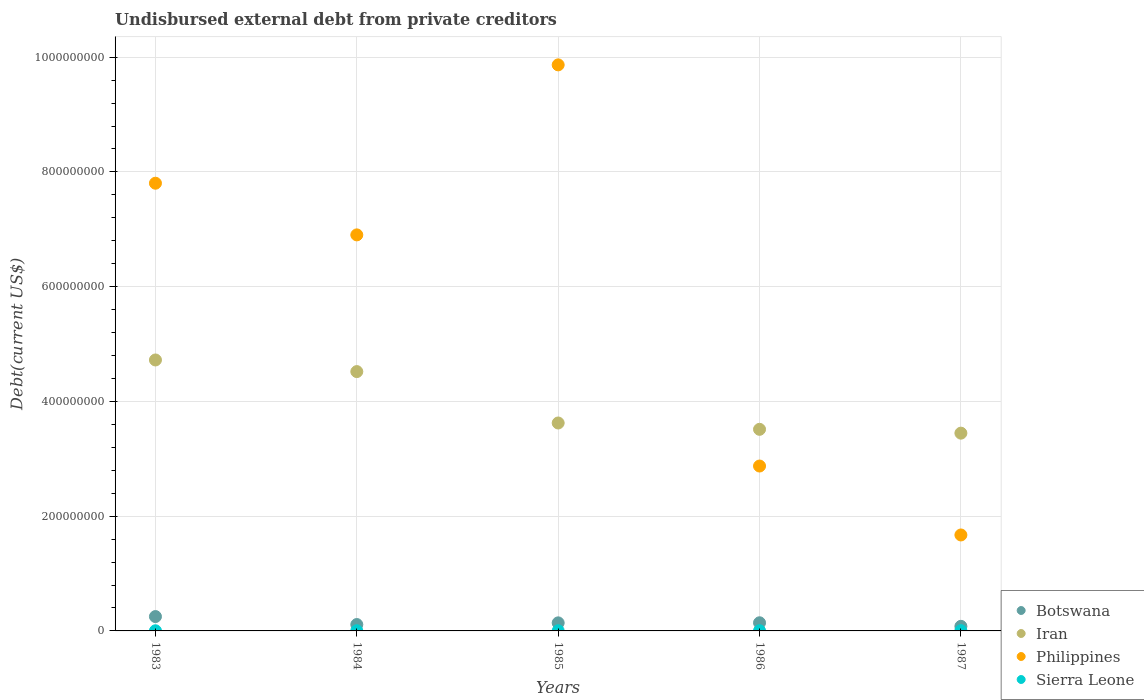How many different coloured dotlines are there?
Your answer should be compact. 4. What is the total debt in Botswana in 1986?
Your response must be concise. 1.42e+07. Across all years, what is the maximum total debt in Philippines?
Ensure brevity in your answer.  9.87e+08. Across all years, what is the minimum total debt in Botswana?
Give a very brief answer. 7.99e+06. In which year was the total debt in Sierra Leone maximum?
Your answer should be very brief. 1987. What is the total total debt in Botswana in the graph?
Provide a succinct answer. 7.24e+07. What is the difference between the total debt in Philippines in 1983 and that in 1984?
Your answer should be compact. 9.00e+07. What is the difference between the total debt in Botswana in 1983 and the total debt in Sierra Leone in 1987?
Make the answer very short. 2.46e+07. What is the average total debt in Philippines per year?
Make the answer very short. 5.82e+08. In the year 1984, what is the difference between the total debt in Sierra Leone and total debt in Botswana?
Keep it short and to the point. -1.08e+07. In how many years, is the total debt in Sierra Leone greater than 160000000 US$?
Provide a succinct answer. 0. What is the ratio of the total debt in Sierra Leone in 1983 to that in 1985?
Make the answer very short. 0.91. Is the total debt in Iran in 1983 less than that in 1985?
Give a very brief answer. No. Is the difference between the total debt in Sierra Leone in 1984 and 1985 greater than the difference between the total debt in Botswana in 1984 and 1985?
Make the answer very short. Yes. What is the difference between the highest and the second highest total debt in Sierra Leone?
Ensure brevity in your answer.  7.20e+04. What is the difference between the highest and the lowest total debt in Botswana?
Make the answer very short. 1.70e+07. In how many years, is the total debt in Iran greater than the average total debt in Iran taken over all years?
Ensure brevity in your answer.  2. Is the sum of the total debt in Sierra Leone in 1985 and 1987 greater than the maximum total debt in Botswana across all years?
Make the answer very short. No. Is it the case that in every year, the sum of the total debt in Iran and total debt in Sierra Leone  is greater than the total debt in Philippines?
Keep it short and to the point. No. Is the total debt in Philippines strictly less than the total debt in Botswana over the years?
Give a very brief answer. No. How many dotlines are there?
Your response must be concise. 4. How many legend labels are there?
Provide a succinct answer. 4. What is the title of the graph?
Make the answer very short. Undisbursed external debt from private creditors. Does "Haiti" appear as one of the legend labels in the graph?
Offer a very short reply. No. What is the label or title of the X-axis?
Offer a terse response. Years. What is the label or title of the Y-axis?
Keep it short and to the point. Debt(current US$). What is the Debt(current US$) of Botswana in 1983?
Offer a terse response. 2.50e+07. What is the Debt(current US$) in Iran in 1983?
Make the answer very short. 4.72e+08. What is the Debt(current US$) of Philippines in 1983?
Offer a very short reply. 7.80e+08. What is the Debt(current US$) in Sierra Leone in 1983?
Provide a succinct answer. 2.67e+05. What is the Debt(current US$) in Botswana in 1984?
Your response must be concise. 1.11e+07. What is the Debt(current US$) in Iran in 1984?
Make the answer very short. 4.52e+08. What is the Debt(current US$) in Philippines in 1984?
Your answer should be compact. 6.90e+08. What is the Debt(current US$) of Sierra Leone in 1984?
Make the answer very short. 2.84e+05. What is the Debt(current US$) in Botswana in 1985?
Your answer should be compact. 1.41e+07. What is the Debt(current US$) of Iran in 1985?
Make the answer very short. 3.62e+08. What is the Debt(current US$) of Philippines in 1985?
Offer a very short reply. 9.87e+08. What is the Debt(current US$) of Sierra Leone in 1985?
Ensure brevity in your answer.  2.94e+05. What is the Debt(current US$) in Botswana in 1986?
Provide a short and direct response. 1.42e+07. What is the Debt(current US$) of Iran in 1986?
Offer a terse response. 3.51e+08. What is the Debt(current US$) of Philippines in 1986?
Ensure brevity in your answer.  2.87e+08. What is the Debt(current US$) of Sierra Leone in 1986?
Make the answer very short. 3.45e+05. What is the Debt(current US$) in Botswana in 1987?
Provide a succinct answer. 7.99e+06. What is the Debt(current US$) of Iran in 1987?
Provide a short and direct response. 3.45e+08. What is the Debt(current US$) in Philippines in 1987?
Give a very brief answer. 1.67e+08. What is the Debt(current US$) in Sierra Leone in 1987?
Give a very brief answer. 4.17e+05. Across all years, what is the maximum Debt(current US$) of Botswana?
Give a very brief answer. 2.50e+07. Across all years, what is the maximum Debt(current US$) in Iran?
Provide a succinct answer. 4.72e+08. Across all years, what is the maximum Debt(current US$) in Philippines?
Offer a terse response. 9.87e+08. Across all years, what is the maximum Debt(current US$) of Sierra Leone?
Offer a very short reply. 4.17e+05. Across all years, what is the minimum Debt(current US$) in Botswana?
Your answer should be very brief. 7.99e+06. Across all years, what is the minimum Debt(current US$) of Iran?
Your response must be concise. 3.45e+08. Across all years, what is the minimum Debt(current US$) in Philippines?
Offer a very short reply. 1.67e+08. Across all years, what is the minimum Debt(current US$) in Sierra Leone?
Keep it short and to the point. 2.67e+05. What is the total Debt(current US$) in Botswana in the graph?
Your answer should be very brief. 7.24e+07. What is the total Debt(current US$) of Iran in the graph?
Your answer should be compact. 1.98e+09. What is the total Debt(current US$) of Philippines in the graph?
Give a very brief answer. 2.91e+09. What is the total Debt(current US$) of Sierra Leone in the graph?
Ensure brevity in your answer.  1.61e+06. What is the difference between the Debt(current US$) of Botswana in 1983 and that in 1984?
Keep it short and to the point. 1.39e+07. What is the difference between the Debt(current US$) of Iran in 1983 and that in 1984?
Keep it short and to the point. 2.03e+07. What is the difference between the Debt(current US$) in Philippines in 1983 and that in 1984?
Offer a very short reply. 9.00e+07. What is the difference between the Debt(current US$) of Sierra Leone in 1983 and that in 1984?
Make the answer very short. -1.70e+04. What is the difference between the Debt(current US$) in Botswana in 1983 and that in 1985?
Give a very brief answer. 1.10e+07. What is the difference between the Debt(current US$) in Iran in 1983 and that in 1985?
Your response must be concise. 1.10e+08. What is the difference between the Debt(current US$) of Philippines in 1983 and that in 1985?
Your answer should be very brief. -2.06e+08. What is the difference between the Debt(current US$) in Sierra Leone in 1983 and that in 1985?
Your answer should be very brief. -2.70e+04. What is the difference between the Debt(current US$) of Botswana in 1983 and that in 1986?
Provide a succinct answer. 1.08e+07. What is the difference between the Debt(current US$) in Iran in 1983 and that in 1986?
Your answer should be compact. 1.21e+08. What is the difference between the Debt(current US$) in Philippines in 1983 and that in 1986?
Offer a very short reply. 4.93e+08. What is the difference between the Debt(current US$) of Sierra Leone in 1983 and that in 1986?
Give a very brief answer. -7.80e+04. What is the difference between the Debt(current US$) of Botswana in 1983 and that in 1987?
Give a very brief answer. 1.70e+07. What is the difference between the Debt(current US$) in Iran in 1983 and that in 1987?
Give a very brief answer. 1.28e+08. What is the difference between the Debt(current US$) in Philippines in 1983 and that in 1987?
Your answer should be very brief. 6.13e+08. What is the difference between the Debt(current US$) of Sierra Leone in 1983 and that in 1987?
Provide a succinct answer. -1.50e+05. What is the difference between the Debt(current US$) in Botswana in 1984 and that in 1985?
Make the answer very short. -2.93e+06. What is the difference between the Debt(current US$) in Iran in 1984 and that in 1985?
Your answer should be compact. 8.96e+07. What is the difference between the Debt(current US$) in Philippines in 1984 and that in 1985?
Make the answer very short. -2.96e+08. What is the difference between the Debt(current US$) in Sierra Leone in 1984 and that in 1985?
Keep it short and to the point. -10000. What is the difference between the Debt(current US$) of Botswana in 1984 and that in 1986?
Make the answer very short. -3.07e+06. What is the difference between the Debt(current US$) in Iran in 1984 and that in 1986?
Your response must be concise. 1.01e+08. What is the difference between the Debt(current US$) in Philippines in 1984 and that in 1986?
Offer a very short reply. 4.03e+08. What is the difference between the Debt(current US$) of Sierra Leone in 1984 and that in 1986?
Make the answer very short. -6.10e+04. What is the difference between the Debt(current US$) in Botswana in 1984 and that in 1987?
Keep it short and to the point. 3.14e+06. What is the difference between the Debt(current US$) in Iran in 1984 and that in 1987?
Ensure brevity in your answer.  1.07e+08. What is the difference between the Debt(current US$) of Philippines in 1984 and that in 1987?
Offer a terse response. 5.23e+08. What is the difference between the Debt(current US$) of Sierra Leone in 1984 and that in 1987?
Your answer should be very brief. -1.33e+05. What is the difference between the Debt(current US$) in Botswana in 1985 and that in 1986?
Make the answer very short. -1.43e+05. What is the difference between the Debt(current US$) in Iran in 1985 and that in 1986?
Keep it short and to the point. 1.10e+07. What is the difference between the Debt(current US$) of Philippines in 1985 and that in 1986?
Give a very brief answer. 6.99e+08. What is the difference between the Debt(current US$) in Sierra Leone in 1985 and that in 1986?
Offer a very short reply. -5.10e+04. What is the difference between the Debt(current US$) in Botswana in 1985 and that in 1987?
Ensure brevity in your answer.  6.06e+06. What is the difference between the Debt(current US$) in Iran in 1985 and that in 1987?
Offer a terse response. 1.77e+07. What is the difference between the Debt(current US$) of Philippines in 1985 and that in 1987?
Make the answer very short. 8.19e+08. What is the difference between the Debt(current US$) of Sierra Leone in 1985 and that in 1987?
Make the answer very short. -1.23e+05. What is the difference between the Debt(current US$) of Botswana in 1986 and that in 1987?
Provide a short and direct response. 6.21e+06. What is the difference between the Debt(current US$) in Iran in 1986 and that in 1987?
Give a very brief answer. 6.68e+06. What is the difference between the Debt(current US$) in Philippines in 1986 and that in 1987?
Your response must be concise. 1.20e+08. What is the difference between the Debt(current US$) of Sierra Leone in 1986 and that in 1987?
Give a very brief answer. -7.20e+04. What is the difference between the Debt(current US$) of Botswana in 1983 and the Debt(current US$) of Iran in 1984?
Make the answer very short. -4.27e+08. What is the difference between the Debt(current US$) of Botswana in 1983 and the Debt(current US$) of Philippines in 1984?
Ensure brevity in your answer.  -6.65e+08. What is the difference between the Debt(current US$) of Botswana in 1983 and the Debt(current US$) of Sierra Leone in 1984?
Keep it short and to the point. 2.47e+07. What is the difference between the Debt(current US$) in Iran in 1983 and the Debt(current US$) in Philippines in 1984?
Make the answer very short. -2.18e+08. What is the difference between the Debt(current US$) in Iran in 1983 and the Debt(current US$) in Sierra Leone in 1984?
Ensure brevity in your answer.  4.72e+08. What is the difference between the Debt(current US$) in Philippines in 1983 and the Debt(current US$) in Sierra Leone in 1984?
Give a very brief answer. 7.80e+08. What is the difference between the Debt(current US$) of Botswana in 1983 and the Debt(current US$) of Iran in 1985?
Make the answer very short. -3.37e+08. What is the difference between the Debt(current US$) of Botswana in 1983 and the Debt(current US$) of Philippines in 1985?
Provide a short and direct response. -9.62e+08. What is the difference between the Debt(current US$) in Botswana in 1983 and the Debt(current US$) in Sierra Leone in 1985?
Your answer should be compact. 2.47e+07. What is the difference between the Debt(current US$) in Iran in 1983 and the Debt(current US$) in Philippines in 1985?
Provide a short and direct response. -5.14e+08. What is the difference between the Debt(current US$) of Iran in 1983 and the Debt(current US$) of Sierra Leone in 1985?
Provide a succinct answer. 4.72e+08. What is the difference between the Debt(current US$) of Philippines in 1983 and the Debt(current US$) of Sierra Leone in 1985?
Give a very brief answer. 7.80e+08. What is the difference between the Debt(current US$) in Botswana in 1983 and the Debt(current US$) in Iran in 1986?
Provide a short and direct response. -3.26e+08. What is the difference between the Debt(current US$) of Botswana in 1983 and the Debt(current US$) of Philippines in 1986?
Ensure brevity in your answer.  -2.62e+08. What is the difference between the Debt(current US$) of Botswana in 1983 and the Debt(current US$) of Sierra Leone in 1986?
Offer a terse response. 2.47e+07. What is the difference between the Debt(current US$) of Iran in 1983 and the Debt(current US$) of Philippines in 1986?
Make the answer very short. 1.85e+08. What is the difference between the Debt(current US$) in Iran in 1983 and the Debt(current US$) in Sierra Leone in 1986?
Your answer should be very brief. 4.72e+08. What is the difference between the Debt(current US$) in Philippines in 1983 and the Debt(current US$) in Sierra Leone in 1986?
Provide a succinct answer. 7.80e+08. What is the difference between the Debt(current US$) of Botswana in 1983 and the Debt(current US$) of Iran in 1987?
Your response must be concise. -3.20e+08. What is the difference between the Debt(current US$) in Botswana in 1983 and the Debt(current US$) in Philippines in 1987?
Offer a very short reply. -1.42e+08. What is the difference between the Debt(current US$) of Botswana in 1983 and the Debt(current US$) of Sierra Leone in 1987?
Your response must be concise. 2.46e+07. What is the difference between the Debt(current US$) in Iran in 1983 and the Debt(current US$) in Philippines in 1987?
Provide a succinct answer. 3.05e+08. What is the difference between the Debt(current US$) of Iran in 1983 and the Debt(current US$) of Sierra Leone in 1987?
Ensure brevity in your answer.  4.72e+08. What is the difference between the Debt(current US$) in Philippines in 1983 and the Debt(current US$) in Sierra Leone in 1987?
Provide a succinct answer. 7.80e+08. What is the difference between the Debt(current US$) of Botswana in 1984 and the Debt(current US$) of Iran in 1985?
Give a very brief answer. -3.51e+08. What is the difference between the Debt(current US$) in Botswana in 1984 and the Debt(current US$) in Philippines in 1985?
Offer a very short reply. -9.75e+08. What is the difference between the Debt(current US$) of Botswana in 1984 and the Debt(current US$) of Sierra Leone in 1985?
Provide a short and direct response. 1.08e+07. What is the difference between the Debt(current US$) in Iran in 1984 and the Debt(current US$) in Philippines in 1985?
Your answer should be very brief. -5.35e+08. What is the difference between the Debt(current US$) of Iran in 1984 and the Debt(current US$) of Sierra Leone in 1985?
Provide a succinct answer. 4.52e+08. What is the difference between the Debt(current US$) in Philippines in 1984 and the Debt(current US$) in Sierra Leone in 1985?
Make the answer very short. 6.90e+08. What is the difference between the Debt(current US$) in Botswana in 1984 and the Debt(current US$) in Iran in 1986?
Your answer should be compact. -3.40e+08. What is the difference between the Debt(current US$) in Botswana in 1984 and the Debt(current US$) in Philippines in 1986?
Provide a succinct answer. -2.76e+08. What is the difference between the Debt(current US$) of Botswana in 1984 and the Debt(current US$) of Sierra Leone in 1986?
Provide a short and direct response. 1.08e+07. What is the difference between the Debt(current US$) of Iran in 1984 and the Debt(current US$) of Philippines in 1986?
Give a very brief answer. 1.65e+08. What is the difference between the Debt(current US$) in Iran in 1984 and the Debt(current US$) in Sierra Leone in 1986?
Offer a very short reply. 4.52e+08. What is the difference between the Debt(current US$) in Philippines in 1984 and the Debt(current US$) in Sierra Leone in 1986?
Make the answer very short. 6.90e+08. What is the difference between the Debt(current US$) in Botswana in 1984 and the Debt(current US$) in Iran in 1987?
Provide a short and direct response. -3.34e+08. What is the difference between the Debt(current US$) in Botswana in 1984 and the Debt(current US$) in Philippines in 1987?
Offer a very short reply. -1.56e+08. What is the difference between the Debt(current US$) in Botswana in 1984 and the Debt(current US$) in Sierra Leone in 1987?
Your answer should be compact. 1.07e+07. What is the difference between the Debt(current US$) in Iran in 1984 and the Debt(current US$) in Philippines in 1987?
Offer a very short reply. 2.85e+08. What is the difference between the Debt(current US$) of Iran in 1984 and the Debt(current US$) of Sierra Leone in 1987?
Ensure brevity in your answer.  4.52e+08. What is the difference between the Debt(current US$) of Philippines in 1984 and the Debt(current US$) of Sierra Leone in 1987?
Make the answer very short. 6.90e+08. What is the difference between the Debt(current US$) of Botswana in 1985 and the Debt(current US$) of Iran in 1986?
Keep it short and to the point. -3.37e+08. What is the difference between the Debt(current US$) in Botswana in 1985 and the Debt(current US$) in Philippines in 1986?
Offer a terse response. -2.73e+08. What is the difference between the Debt(current US$) in Botswana in 1985 and the Debt(current US$) in Sierra Leone in 1986?
Keep it short and to the point. 1.37e+07. What is the difference between the Debt(current US$) in Iran in 1985 and the Debt(current US$) in Philippines in 1986?
Ensure brevity in your answer.  7.50e+07. What is the difference between the Debt(current US$) in Iran in 1985 and the Debt(current US$) in Sierra Leone in 1986?
Make the answer very short. 3.62e+08. What is the difference between the Debt(current US$) of Philippines in 1985 and the Debt(current US$) of Sierra Leone in 1986?
Ensure brevity in your answer.  9.86e+08. What is the difference between the Debt(current US$) of Botswana in 1985 and the Debt(current US$) of Iran in 1987?
Offer a very short reply. -3.31e+08. What is the difference between the Debt(current US$) of Botswana in 1985 and the Debt(current US$) of Philippines in 1987?
Your answer should be compact. -1.53e+08. What is the difference between the Debt(current US$) in Botswana in 1985 and the Debt(current US$) in Sierra Leone in 1987?
Ensure brevity in your answer.  1.36e+07. What is the difference between the Debt(current US$) of Iran in 1985 and the Debt(current US$) of Philippines in 1987?
Give a very brief answer. 1.95e+08. What is the difference between the Debt(current US$) of Iran in 1985 and the Debt(current US$) of Sierra Leone in 1987?
Provide a short and direct response. 3.62e+08. What is the difference between the Debt(current US$) of Philippines in 1985 and the Debt(current US$) of Sierra Leone in 1987?
Keep it short and to the point. 9.86e+08. What is the difference between the Debt(current US$) in Botswana in 1986 and the Debt(current US$) in Iran in 1987?
Provide a short and direct response. -3.30e+08. What is the difference between the Debt(current US$) of Botswana in 1986 and the Debt(current US$) of Philippines in 1987?
Offer a terse response. -1.53e+08. What is the difference between the Debt(current US$) in Botswana in 1986 and the Debt(current US$) in Sierra Leone in 1987?
Your response must be concise. 1.38e+07. What is the difference between the Debt(current US$) in Iran in 1986 and the Debt(current US$) in Philippines in 1987?
Offer a terse response. 1.84e+08. What is the difference between the Debt(current US$) of Iran in 1986 and the Debt(current US$) of Sierra Leone in 1987?
Your answer should be very brief. 3.51e+08. What is the difference between the Debt(current US$) in Philippines in 1986 and the Debt(current US$) in Sierra Leone in 1987?
Make the answer very short. 2.87e+08. What is the average Debt(current US$) of Botswana per year?
Offer a terse response. 1.45e+07. What is the average Debt(current US$) in Iran per year?
Provide a succinct answer. 3.97e+08. What is the average Debt(current US$) in Philippines per year?
Keep it short and to the point. 5.82e+08. What is the average Debt(current US$) of Sierra Leone per year?
Provide a succinct answer. 3.21e+05. In the year 1983, what is the difference between the Debt(current US$) of Botswana and Debt(current US$) of Iran?
Make the answer very short. -4.47e+08. In the year 1983, what is the difference between the Debt(current US$) in Botswana and Debt(current US$) in Philippines?
Provide a short and direct response. -7.55e+08. In the year 1983, what is the difference between the Debt(current US$) of Botswana and Debt(current US$) of Sierra Leone?
Make the answer very short. 2.47e+07. In the year 1983, what is the difference between the Debt(current US$) of Iran and Debt(current US$) of Philippines?
Offer a very short reply. -3.08e+08. In the year 1983, what is the difference between the Debt(current US$) in Iran and Debt(current US$) in Sierra Leone?
Offer a very short reply. 4.72e+08. In the year 1983, what is the difference between the Debt(current US$) of Philippines and Debt(current US$) of Sierra Leone?
Your answer should be compact. 7.80e+08. In the year 1984, what is the difference between the Debt(current US$) in Botswana and Debt(current US$) in Iran?
Make the answer very short. -4.41e+08. In the year 1984, what is the difference between the Debt(current US$) of Botswana and Debt(current US$) of Philippines?
Your answer should be compact. -6.79e+08. In the year 1984, what is the difference between the Debt(current US$) of Botswana and Debt(current US$) of Sierra Leone?
Your answer should be compact. 1.08e+07. In the year 1984, what is the difference between the Debt(current US$) in Iran and Debt(current US$) in Philippines?
Make the answer very short. -2.38e+08. In the year 1984, what is the difference between the Debt(current US$) of Iran and Debt(current US$) of Sierra Leone?
Offer a very short reply. 4.52e+08. In the year 1984, what is the difference between the Debt(current US$) in Philippines and Debt(current US$) in Sierra Leone?
Provide a succinct answer. 6.90e+08. In the year 1985, what is the difference between the Debt(current US$) in Botswana and Debt(current US$) in Iran?
Your answer should be very brief. -3.48e+08. In the year 1985, what is the difference between the Debt(current US$) of Botswana and Debt(current US$) of Philippines?
Provide a succinct answer. -9.72e+08. In the year 1985, what is the difference between the Debt(current US$) of Botswana and Debt(current US$) of Sierra Leone?
Ensure brevity in your answer.  1.38e+07. In the year 1985, what is the difference between the Debt(current US$) of Iran and Debt(current US$) of Philippines?
Make the answer very short. -6.24e+08. In the year 1985, what is the difference between the Debt(current US$) in Iran and Debt(current US$) in Sierra Leone?
Keep it short and to the point. 3.62e+08. In the year 1985, what is the difference between the Debt(current US$) of Philippines and Debt(current US$) of Sierra Leone?
Offer a terse response. 9.86e+08. In the year 1986, what is the difference between the Debt(current US$) in Botswana and Debt(current US$) in Iran?
Offer a very short reply. -3.37e+08. In the year 1986, what is the difference between the Debt(current US$) in Botswana and Debt(current US$) in Philippines?
Give a very brief answer. -2.73e+08. In the year 1986, what is the difference between the Debt(current US$) of Botswana and Debt(current US$) of Sierra Leone?
Your answer should be very brief. 1.38e+07. In the year 1986, what is the difference between the Debt(current US$) in Iran and Debt(current US$) in Philippines?
Provide a short and direct response. 6.40e+07. In the year 1986, what is the difference between the Debt(current US$) in Iran and Debt(current US$) in Sierra Leone?
Provide a succinct answer. 3.51e+08. In the year 1986, what is the difference between the Debt(current US$) in Philippines and Debt(current US$) in Sierra Leone?
Provide a succinct answer. 2.87e+08. In the year 1987, what is the difference between the Debt(current US$) of Botswana and Debt(current US$) of Iran?
Offer a very short reply. -3.37e+08. In the year 1987, what is the difference between the Debt(current US$) in Botswana and Debt(current US$) in Philippines?
Offer a very short reply. -1.59e+08. In the year 1987, what is the difference between the Debt(current US$) in Botswana and Debt(current US$) in Sierra Leone?
Give a very brief answer. 7.57e+06. In the year 1987, what is the difference between the Debt(current US$) of Iran and Debt(current US$) of Philippines?
Provide a short and direct response. 1.77e+08. In the year 1987, what is the difference between the Debt(current US$) of Iran and Debt(current US$) of Sierra Leone?
Offer a very short reply. 3.44e+08. In the year 1987, what is the difference between the Debt(current US$) in Philippines and Debt(current US$) in Sierra Leone?
Give a very brief answer. 1.67e+08. What is the ratio of the Debt(current US$) of Botswana in 1983 to that in 1984?
Give a very brief answer. 2.25. What is the ratio of the Debt(current US$) in Iran in 1983 to that in 1984?
Your response must be concise. 1.04. What is the ratio of the Debt(current US$) of Philippines in 1983 to that in 1984?
Keep it short and to the point. 1.13. What is the ratio of the Debt(current US$) of Sierra Leone in 1983 to that in 1984?
Keep it short and to the point. 0.94. What is the ratio of the Debt(current US$) of Botswana in 1983 to that in 1985?
Keep it short and to the point. 1.78. What is the ratio of the Debt(current US$) of Iran in 1983 to that in 1985?
Give a very brief answer. 1.3. What is the ratio of the Debt(current US$) in Philippines in 1983 to that in 1985?
Provide a succinct answer. 0.79. What is the ratio of the Debt(current US$) in Sierra Leone in 1983 to that in 1985?
Offer a very short reply. 0.91. What is the ratio of the Debt(current US$) in Botswana in 1983 to that in 1986?
Your answer should be compact. 1.76. What is the ratio of the Debt(current US$) in Iran in 1983 to that in 1986?
Provide a short and direct response. 1.34. What is the ratio of the Debt(current US$) of Philippines in 1983 to that in 1986?
Keep it short and to the point. 2.72. What is the ratio of the Debt(current US$) of Sierra Leone in 1983 to that in 1986?
Your response must be concise. 0.77. What is the ratio of the Debt(current US$) in Botswana in 1983 to that in 1987?
Provide a short and direct response. 3.13. What is the ratio of the Debt(current US$) in Iran in 1983 to that in 1987?
Ensure brevity in your answer.  1.37. What is the ratio of the Debt(current US$) of Philippines in 1983 to that in 1987?
Make the answer very short. 4.67. What is the ratio of the Debt(current US$) of Sierra Leone in 1983 to that in 1987?
Your response must be concise. 0.64. What is the ratio of the Debt(current US$) in Botswana in 1984 to that in 1985?
Give a very brief answer. 0.79. What is the ratio of the Debt(current US$) of Iran in 1984 to that in 1985?
Make the answer very short. 1.25. What is the ratio of the Debt(current US$) of Philippines in 1984 to that in 1985?
Provide a succinct answer. 0.7. What is the ratio of the Debt(current US$) in Sierra Leone in 1984 to that in 1985?
Offer a terse response. 0.97. What is the ratio of the Debt(current US$) of Botswana in 1984 to that in 1986?
Your response must be concise. 0.78. What is the ratio of the Debt(current US$) of Iran in 1984 to that in 1986?
Ensure brevity in your answer.  1.29. What is the ratio of the Debt(current US$) in Philippines in 1984 to that in 1986?
Keep it short and to the point. 2.4. What is the ratio of the Debt(current US$) of Sierra Leone in 1984 to that in 1986?
Provide a short and direct response. 0.82. What is the ratio of the Debt(current US$) of Botswana in 1984 to that in 1987?
Offer a very short reply. 1.39. What is the ratio of the Debt(current US$) in Iran in 1984 to that in 1987?
Provide a succinct answer. 1.31. What is the ratio of the Debt(current US$) in Philippines in 1984 to that in 1987?
Provide a short and direct response. 4.13. What is the ratio of the Debt(current US$) in Sierra Leone in 1984 to that in 1987?
Provide a succinct answer. 0.68. What is the ratio of the Debt(current US$) of Botswana in 1985 to that in 1986?
Provide a short and direct response. 0.99. What is the ratio of the Debt(current US$) of Iran in 1985 to that in 1986?
Provide a succinct answer. 1.03. What is the ratio of the Debt(current US$) in Philippines in 1985 to that in 1986?
Your response must be concise. 3.43. What is the ratio of the Debt(current US$) of Sierra Leone in 1985 to that in 1986?
Your answer should be compact. 0.85. What is the ratio of the Debt(current US$) in Botswana in 1985 to that in 1987?
Provide a succinct answer. 1.76. What is the ratio of the Debt(current US$) in Iran in 1985 to that in 1987?
Provide a short and direct response. 1.05. What is the ratio of the Debt(current US$) of Philippines in 1985 to that in 1987?
Provide a short and direct response. 5.9. What is the ratio of the Debt(current US$) of Sierra Leone in 1985 to that in 1987?
Offer a very short reply. 0.7. What is the ratio of the Debt(current US$) in Botswana in 1986 to that in 1987?
Offer a very short reply. 1.78. What is the ratio of the Debt(current US$) in Iran in 1986 to that in 1987?
Ensure brevity in your answer.  1.02. What is the ratio of the Debt(current US$) in Philippines in 1986 to that in 1987?
Provide a short and direct response. 1.72. What is the ratio of the Debt(current US$) in Sierra Leone in 1986 to that in 1987?
Your response must be concise. 0.83. What is the difference between the highest and the second highest Debt(current US$) in Botswana?
Offer a terse response. 1.08e+07. What is the difference between the highest and the second highest Debt(current US$) in Iran?
Your answer should be compact. 2.03e+07. What is the difference between the highest and the second highest Debt(current US$) in Philippines?
Ensure brevity in your answer.  2.06e+08. What is the difference between the highest and the second highest Debt(current US$) in Sierra Leone?
Make the answer very short. 7.20e+04. What is the difference between the highest and the lowest Debt(current US$) of Botswana?
Offer a terse response. 1.70e+07. What is the difference between the highest and the lowest Debt(current US$) in Iran?
Your answer should be very brief. 1.28e+08. What is the difference between the highest and the lowest Debt(current US$) in Philippines?
Provide a succinct answer. 8.19e+08. What is the difference between the highest and the lowest Debt(current US$) in Sierra Leone?
Offer a very short reply. 1.50e+05. 